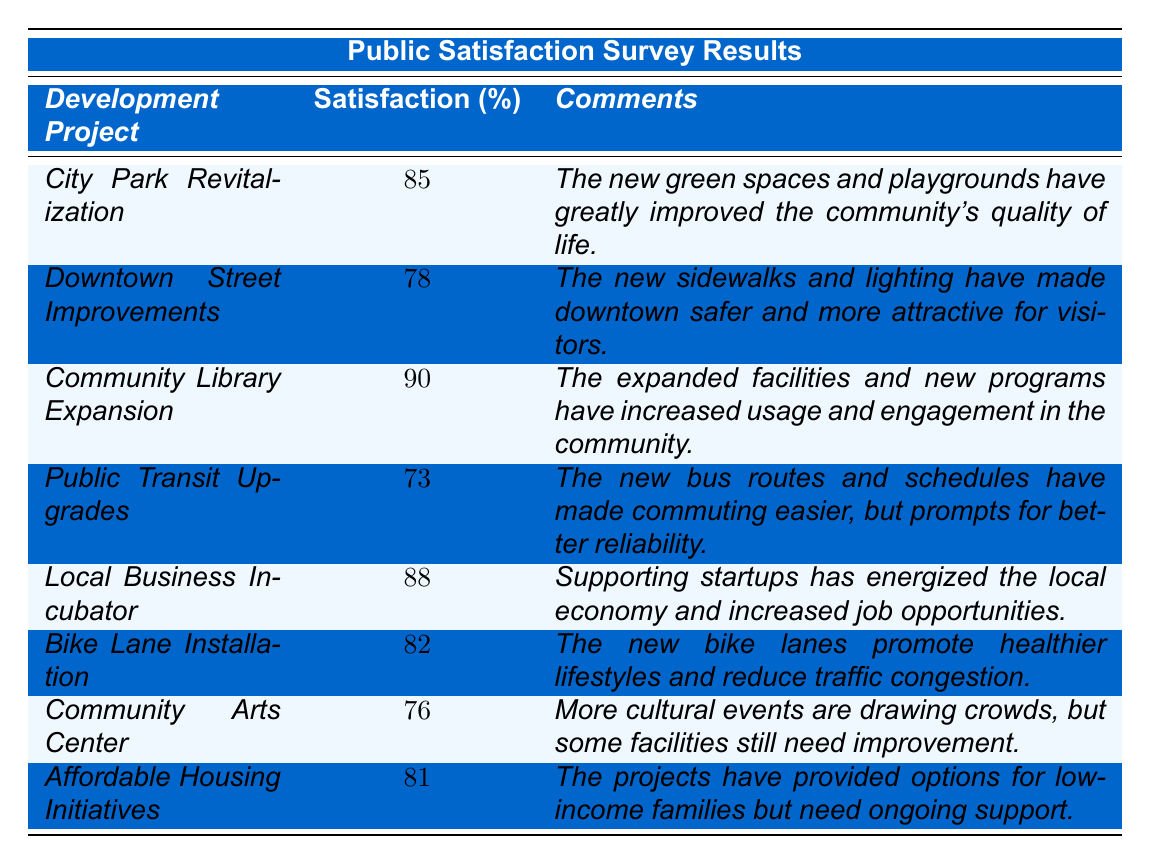What is the satisfaction percentage for the Community Library Expansion project? The table shows that the satisfaction percentage for the Community Library Expansion is listed as 90% in the relevant row.
Answer: 90% Which development project received the highest satisfaction percentage? Upon examining the satisfaction percentages in the table, the Community Library Expansion with 90% is the highest.
Answer: Community Library Expansion What is the difference in satisfaction percentage between the City Park Revitalization and the Downtown Street Improvements? The City Park Revitalization has a satisfaction percentage of 85%, and Downtown Street Improvements has 78%. The difference is calculated as 85 - 78 = 7.
Answer: 7% How many development projects have a satisfaction percentage above 80%? By reviewing the table, there are four projects with a satisfaction percentage above 80%: City Park Revitalization (85%), Community Library Expansion (90%), Local Business Incubator (88%), and Bike Lane Installation (82%).
Answer: 4 Is the public more satisfied with the Local Business Incubator or the Community Arts Center? The satisfaction percentage for the Local Business Incubator is 88% whereas for the Community Arts Center it is 76%. This indicates higher satisfaction for the Local Business Incubator.
Answer: Yes What is the average satisfaction percentage of all the development projects listed? The total satisfaction percentages are 85 + 78 + 90 + 73 + 88 + 82 + 76 + 81 =  655. There are 8 projects, so the average is 655 / 8 = 81.875.
Answer: 81.875 Which development project has the lowest satisfaction percentage and what is it? The Public Transit Upgrades project has the lowest satisfaction percentage, listed as 73% in the table.
Answer: Public Transit Upgrades, 73% What percentage of the projects listed achieved a satisfaction rate of 75% or higher? Out of the 8 projects, 6 have a satisfaction rate of 75% or higher (all except Public Transit Upgrades and Community Arts Center). The percentage is (6/8) * 100 = 75%.
Answer: 75% 